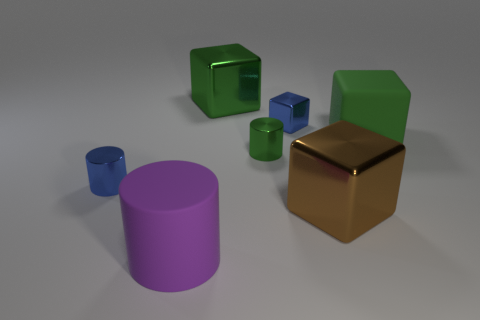There is a green thing that is left of the tiny metallic block and in front of the big green metallic thing; what material is it?
Keep it short and to the point. Metal. Is the big brown block made of the same material as the green cylinder?
Make the answer very short. Yes. How many large purple rubber objects are there?
Make the answer very short. 1. What is the color of the small metallic cylinder that is behind the tiny blue thing left of the tiny cube that is behind the small blue cylinder?
Provide a short and direct response. Green. Do the big rubber block and the rubber cylinder have the same color?
Your answer should be very brief. No. How many tiny objects are both on the right side of the large purple cylinder and in front of the small metallic block?
Ensure brevity in your answer.  1. What number of metallic objects are cyan cylinders or small green cylinders?
Give a very brief answer. 1. What is the material of the tiny green thing that is to the right of the big metal block that is behind the big brown metallic object?
Keep it short and to the point. Metal. What shape is the large object that is the same color as the matte block?
Your answer should be compact. Cube. What shape is the metal object that is the same size as the brown shiny cube?
Your response must be concise. Cube. 